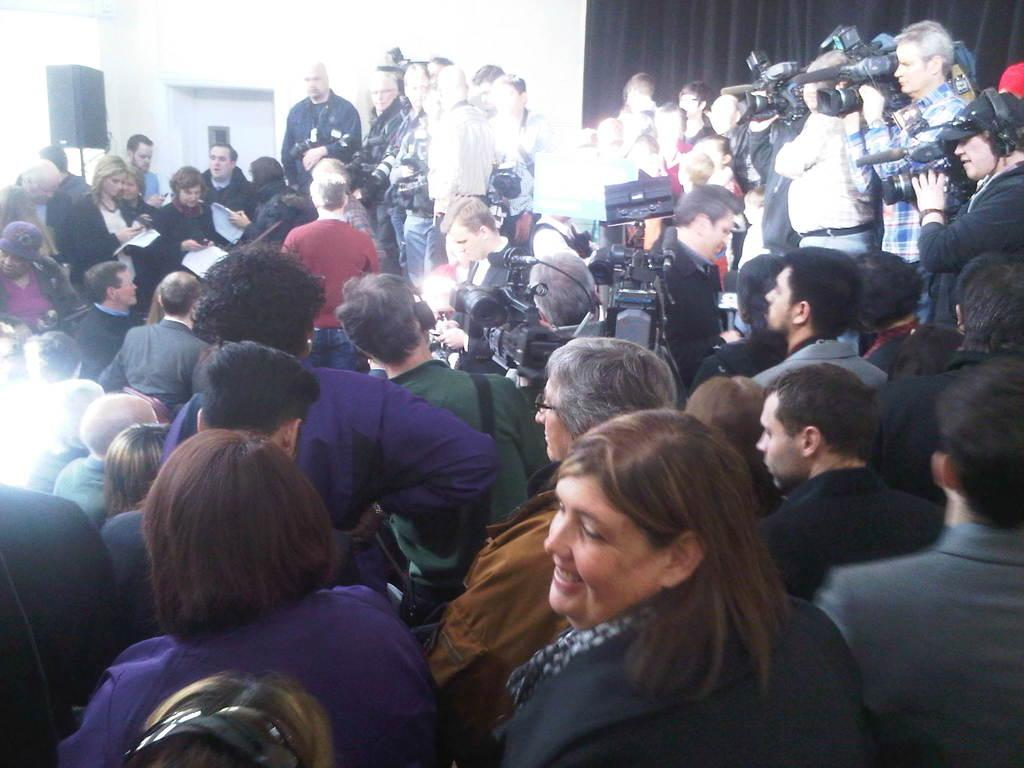How many people are present in the image? There are many people in the image. What are the people doing in the image? The people are standing in a place. Can you identify any specific individuals in the image? Yes, there are media persons in the center of the image. What equipment are the media persons using? The media persons are using video cameras and microphones. What type of oil can be seen dripping from the ladybug in the image? There is no ladybug or oil present in the image. How does the sponge absorb the water in the image? There is no sponge or water present in the image. 